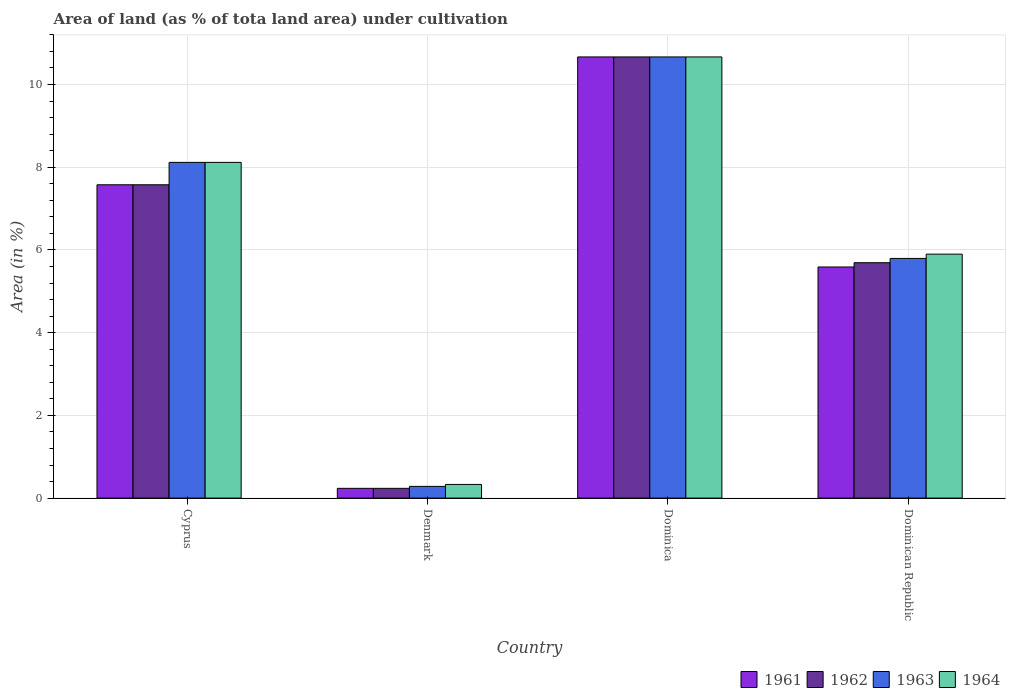How many groups of bars are there?
Make the answer very short. 4. Are the number of bars per tick equal to the number of legend labels?
Offer a very short reply. Yes. Are the number of bars on each tick of the X-axis equal?
Provide a short and direct response. Yes. How many bars are there on the 4th tick from the left?
Ensure brevity in your answer.  4. What is the label of the 4th group of bars from the left?
Make the answer very short. Dominican Republic. What is the percentage of land under cultivation in 1961 in Dominica?
Make the answer very short. 10.67. Across all countries, what is the maximum percentage of land under cultivation in 1964?
Keep it short and to the point. 10.67. Across all countries, what is the minimum percentage of land under cultivation in 1964?
Offer a very short reply. 0.33. In which country was the percentage of land under cultivation in 1961 maximum?
Your answer should be compact. Dominica. In which country was the percentage of land under cultivation in 1963 minimum?
Offer a terse response. Denmark. What is the total percentage of land under cultivation in 1961 in the graph?
Keep it short and to the point. 24.07. What is the difference between the percentage of land under cultivation in 1962 in Dominica and that in Dominican Republic?
Give a very brief answer. 4.98. What is the difference between the percentage of land under cultivation in 1964 in Cyprus and the percentage of land under cultivation in 1963 in Denmark?
Provide a succinct answer. 7.83. What is the average percentage of land under cultivation in 1961 per country?
Keep it short and to the point. 6.02. What is the difference between the percentage of land under cultivation of/in 1964 and percentage of land under cultivation of/in 1962 in Denmark?
Provide a succinct answer. 0.09. In how many countries, is the percentage of land under cultivation in 1962 greater than 4.8 %?
Provide a succinct answer. 3. What is the ratio of the percentage of land under cultivation in 1961 in Dominica to that in Dominican Republic?
Ensure brevity in your answer.  1.91. Is the percentage of land under cultivation in 1964 in Cyprus less than that in Denmark?
Your answer should be very brief. No. What is the difference between the highest and the second highest percentage of land under cultivation in 1963?
Offer a very short reply. -2.55. What is the difference between the highest and the lowest percentage of land under cultivation in 1963?
Make the answer very short. 10.38. In how many countries, is the percentage of land under cultivation in 1962 greater than the average percentage of land under cultivation in 1962 taken over all countries?
Your response must be concise. 2. What does the 4th bar from the right in Cyprus represents?
Provide a short and direct response. 1961. Is it the case that in every country, the sum of the percentage of land under cultivation in 1961 and percentage of land under cultivation in 1964 is greater than the percentage of land under cultivation in 1963?
Ensure brevity in your answer.  Yes. How many bars are there?
Offer a terse response. 16. How many countries are there in the graph?
Ensure brevity in your answer.  4. Are the values on the major ticks of Y-axis written in scientific E-notation?
Your response must be concise. No. Does the graph contain any zero values?
Ensure brevity in your answer.  No. Where does the legend appear in the graph?
Ensure brevity in your answer.  Bottom right. How are the legend labels stacked?
Ensure brevity in your answer.  Horizontal. What is the title of the graph?
Ensure brevity in your answer.  Area of land (as % of tota land area) under cultivation. Does "1988" appear as one of the legend labels in the graph?
Your response must be concise. No. What is the label or title of the X-axis?
Provide a short and direct response. Country. What is the label or title of the Y-axis?
Provide a succinct answer. Area (in %). What is the Area (in %) in 1961 in Cyprus?
Ensure brevity in your answer.  7.58. What is the Area (in %) in 1962 in Cyprus?
Your response must be concise. 7.58. What is the Area (in %) in 1963 in Cyprus?
Offer a terse response. 8.12. What is the Area (in %) in 1964 in Cyprus?
Offer a terse response. 8.12. What is the Area (in %) in 1961 in Denmark?
Keep it short and to the point. 0.24. What is the Area (in %) of 1962 in Denmark?
Provide a short and direct response. 0.24. What is the Area (in %) of 1963 in Denmark?
Provide a succinct answer. 0.28. What is the Area (in %) in 1964 in Denmark?
Offer a terse response. 0.33. What is the Area (in %) of 1961 in Dominica?
Ensure brevity in your answer.  10.67. What is the Area (in %) of 1962 in Dominica?
Provide a short and direct response. 10.67. What is the Area (in %) in 1963 in Dominica?
Make the answer very short. 10.67. What is the Area (in %) of 1964 in Dominica?
Your answer should be very brief. 10.67. What is the Area (in %) in 1961 in Dominican Republic?
Your answer should be very brief. 5.59. What is the Area (in %) of 1962 in Dominican Republic?
Provide a succinct answer. 5.69. What is the Area (in %) in 1963 in Dominican Republic?
Provide a succinct answer. 5.79. What is the Area (in %) of 1964 in Dominican Republic?
Keep it short and to the point. 5.9. Across all countries, what is the maximum Area (in %) of 1961?
Provide a succinct answer. 10.67. Across all countries, what is the maximum Area (in %) in 1962?
Your response must be concise. 10.67. Across all countries, what is the maximum Area (in %) of 1963?
Provide a short and direct response. 10.67. Across all countries, what is the maximum Area (in %) of 1964?
Give a very brief answer. 10.67. Across all countries, what is the minimum Area (in %) in 1961?
Keep it short and to the point. 0.24. Across all countries, what is the minimum Area (in %) of 1962?
Offer a terse response. 0.24. Across all countries, what is the minimum Area (in %) in 1963?
Provide a short and direct response. 0.28. Across all countries, what is the minimum Area (in %) in 1964?
Provide a short and direct response. 0.33. What is the total Area (in %) of 1961 in the graph?
Your answer should be compact. 24.07. What is the total Area (in %) in 1962 in the graph?
Give a very brief answer. 24.17. What is the total Area (in %) in 1963 in the graph?
Your answer should be very brief. 24.86. What is the total Area (in %) of 1964 in the graph?
Ensure brevity in your answer.  25.01. What is the difference between the Area (in %) in 1961 in Cyprus and that in Denmark?
Offer a terse response. 7.34. What is the difference between the Area (in %) of 1962 in Cyprus and that in Denmark?
Provide a short and direct response. 7.34. What is the difference between the Area (in %) of 1963 in Cyprus and that in Denmark?
Offer a very short reply. 7.83. What is the difference between the Area (in %) of 1964 in Cyprus and that in Denmark?
Your answer should be compact. 7.79. What is the difference between the Area (in %) in 1961 in Cyprus and that in Dominica?
Provide a succinct answer. -3.09. What is the difference between the Area (in %) in 1962 in Cyprus and that in Dominica?
Offer a terse response. -3.09. What is the difference between the Area (in %) in 1963 in Cyprus and that in Dominica?
Offer a very short reply. -2.55. What is the difference between the Area (in %) of 1964 in Cyprus and that in Dominica?
Provide a short and direct response. -2.55. What is the difference between the Area (in %) in 1961 in Cyprus and that in Dominican Republic?
Your answer should be compact. 1.99. What is the difference between the Area (in %) in 1962 in Cyprus and that in Dominican Republic?
Give a very brief answer. 1.88. What is the difference between the Area (in %) in 1963 in Cyprus and that in Dominican Republic?
Provide a succinct answer. 2.32. What is the difference between the Area (in %) of 1964 in Cyprus and that in Dominican Republic?
Provide a succinct answer. 2.22. What is the difference between the Area (in %) of 1961 in Denmark and that in Dominica?
Keep it short and to the point. -10.43. What is the difference between the Area (in %) in 1962 in Denmark and that in Dominica?
Offer a very short reply. -10.43. What is the difference between the Area (in %) of 1963 in Denmark and that in Dominica?
Keep it short and to the point. -10.38. What is the difference between the Area (in %) of 1964 in Denmark and that in Dominica?
Keep it short and to the point. -10.34. What is the difference between the Area (in %) of 1961 in Denmark and that in Dominican Republic?
Provide a succinct answer. -5.35. What is the difference between the Area (in %) in 1962 in Denmark and that in Dominican Republic?
Ensure brevity in your answer.  -5.46. What is the difference between the Area (in %) in 1963 in Denmark and that in Dominican Republic?
Your answer should be very brief. -5.51. What is the difference between the Area (in %) in 1964 in Denmark and that in Dominican Republic?
Keep it short and to the point. -5.57. What is the difference between the Area (in %) in 1961 in Dominica and that in Dominican Republic?
Ensure brevity in your answer.  5.08. What is the difference between the Area (in %) in 1962 in Dominica and that in Dominican Republic?
Your response must be concise. 4.98. What is the difference between the Area (in %) of 1963 in Dominica and that in Dominican Republic?
Offer a terse response. 4.87. What is the difference between the Area (in %) in 1964 in Dominica and that in Dominican Republic?
Offer a terse response. 4.77. What is the difference between the Area (in %) in 1961 in Cyprus and the Area (in %) in 1962 in Denmark?
Your answer should be compact. 7.34. What is the difference between the Area (in %) in 1961 in Cyprus and the Area (in %) in 1963 in Denmark?
Your answer should be compact. 7.29. What is the difference between the Area (in %) of 1961 in Cyprus and the Area (in %) of 1964 in Denmark?
Provide a succinct answer. 7.25. What is the difference between the Area (in %) of 1962 in Cyprus and the Area (in %) of 1963 in Denmark?
Give a very brief answer. 7.29. What is the difference between the Area (in %) of 1962 in Cyprus and the Area (in %) of 1964 in Denmark?
Make the answer very short. 7.25. What is the difference between the Area (in %) in 1963 in Cyprus and the Area (in %) in 1964 in Denmark?
Your response must be concise. 7.79. What is the difference between the Area (in %) in 1961 in Cyprus and the Area (in %) in 1962 in Dominica?
Provide a short and direct response. -3.09. What is the difference between the Area (in %) in 1961 in Cyprus and the Area (in %) in 1963 in Dominica?
Your response must be concise. -3.09. What is the difference between the Area (in %) of 1961 in Cyprus and the Area (in %) of 1964 in Dominica?
Provide a short and direct response. -3.09. What is the difference between the Area (in %) in 1962 in Cyprus and the Area (in %) in 1963 in Dominica?
Ensure brevity in your answer.  -3.09. What is the difference between the Area (in %) in 1962 in Cyprus and the Area (in %) in 1964 in Dominica?
Ensure brevity in your answer.  -3.09. What is the difference between the Area (in %) in 1963 in Cyprus and the Area (in %) in 1964 in Dominica?
Provide a short and direct response. -2.55. What is the difference between the Area (in %) in 1961 in Cyprus and the Area (in %) in 1962 in Dominican Republic?
Keep it short and to the point. 1.88. What is the difference between the Area (in %) of 1961 in Cyprus and the Area (in %) of 1963 in Dominican Republic?
Offer a terse response. 1.78. What is the difference between the Area (in %) in 1961 in Cyprus and the Area (in %) in 1964 in Dominican Republic?
Provide a succinct answer. 1.68. What is the difference between the Area (in %) of 1962 in Cyprus and the Area (in %) of 1963 in Dominican Republic?
Ensure brevity in your answer.  1.78. What is the difference between the Area (in %) of 1962 in Cyprus and the Area (in %) of 1964 in Dominican Republic?
Offer a very short reply. 1.68. What is the difference between the Area (in %) in 1963 in Cyprus and the Area (in %) in 1964 in Dominican Republic?
Ensure brevity in your answer.  2.22. What is the difference between the Area (in %) of 1961 in Denmark and the Area (in %) of 1962 in Dominica?
Your answer should be compact. -10.43. What is the difference between the Area (in %) in 1961 in Denmark and the Area (in %) in 1963 in Dominica?
Offer a very short reply. -10.43. What is the difference between the Area (in %) in 1961 in Denmark and the Area (in %) in 1964 in Dominica?
Make the answer very short. -10.43. What is the difference between the Area (in %) in 1962 in Denmark and the Area (in %) in 1963 in Dominica?
Give a very brief answer. -10.43. What is the difference between the Area (in %) of 1962 in Denmark and the Area (in %) of 1964 in Dominica?
Your answer should be very brief. -10.43. What is the difference between the Area (in %) of 1963 in Denmark and the Area (in %) of 1964 in Dominica?
Your response must be concise. -10.38. What is the difference between the Area (in %) of 1961 in Denmark and the Area (in %) of 1962 in Dominican Republic?
Provide a short and direct response. -5.46. What is the difference between the Area (in %) in 1961 in Denmark and the Area (in %) in 1963 in Dominican Republic?
Give a very brief answer. -5.56. What is the difference between the Area (in %) in 1961 in Denmark and the Area (in %) in 1964 in Dominican Republic?
Provide a short and direct response. -5.66. What is the difference between the Area (in %) of 1962 in Denmark and the Area (in %) of 1963 in Dominican Republic?
Make the answer very short. -5.56. What is the difference between the Area (in %) in 1962 in Denmark and the Area (in %) in 1964 in Dominican Republic?
Your response must be concise. -5.66. What is the difference between the Area (in %) in 1963 in Denmark and the Area (in %) in 1964 in Dominican Republic?
Make the answer very short. -5.62. What is the difference between the Area (in %) of 1961 in Dominica and the Area (in %) of 1962 in Dominican Republic?
Provide a succinct answer. 4.98. What is the difference between the Area (in %) in 1961 in Dominica and the Area (in %) in 1963 in Dominican Republic?
Ensure brevity in your answer.  4.87. What is the difference between the Area (in %) in 1961 in Dominica and the Area (in %) in 1964 in Dominican Republic?
Offer a terse response. 4.77. What is the difference between the Area (in %) in 1962 in Dominica and the Area (in %) in 1963 in Dominican Republic?
Give a very brief answer. 4.87. What is the difference between the Area (in %) of 1962 in Dominica and the Area (in %) of 1964 in Dominican Republic?
Provide a succinct answer. 4.77. What is the difference between the Area (in %) in 1963 in Dominica and the Area (in %) in 1964 in Dominican Republic?
Offer a terse response. 4.77. What is the average Area (in %) in 1961 per country?
Offer a very short reply. 6.02. What is the average Area (in %) of 1962 per country?
Your answer should be very brief. 6.04. What is the average Area (in %) in 1963 per country?
Offer a very short reply. 6.22. What is the average Area (in %) of 1964 per country?
Your response must be concise. 6.25. What is the difference between the Area (in %) of 1961 and Area (in %) of 1963 in Cyprus?
Make the answer very short. -0.54. What is the difference between the Area (in %) of 1961 and Area (in %) of 1964 in Cyprus?
Your response must be concise. -0.54. What is the difference between the Area (in %) in 1962 and Area (in %) in 1963 in Cyprus?
Give a very brief answer. -0.54. What is the difference between the Area (in %) in 1962 and Area (in %) in 1964 in Cyprus?
Offer a terse response. -0.54. What is the difference between the Area (in %) of 1961 and Area (in %) of 1962 in Denmark?
Provide a short and direct response. 0. What is the difference between the Area (in %) in 1961 and Area (in %) in 1963 in Denmark?
Offer a very short reply. -0.05. What is the difference between the Area (in %) of 1961 and Area (in %) of 1964 in Denmark?
Offer a terse response. -0.09. What is the difference between the Area (in %) in 1962 and Area (in %) in 1963 in Denmark?
Your answer should be compact. -0.05. What is the difference between the Area (in %) of 1962 and Area (in %) of 1964 in Denmark?
Keep it short and to the point. -0.09. What is the difference between the Area (in %) of 1963 and Area (in %) of 1964 in Denmark?
Ensure brevity in your answer.  -0.05. What is the difference between the Area (in %) in 1961 and Area (in %) in 1963 in Dominica?
Keep it short and to the point. 0. What is the difference between the Area (in %) of 1961 and Area (in %) of 1964 in Dominica?
Ensure brevity in your answer.  0. What is the difference between the Area (in %) of 1962 and Area (in %) of 1964 in Dominica?
Offer a very short reply. 0. What is the difference between the Area (in %) in 1963 and Area (in %) in 1964 in Dominica?
Your answer should be very brief. 0. What is the difference between the Area (in %) of 1961 and Area (in %) of 1962 in Dominican Republic?
Offer a very short reply. -0.1. What is the difference between the Area (in %) of 1961 and Area (in %) of 1963 in Dominican Republic?
Provide a short and direct response. -0.21. What is the difference between the Area (in %) of 1961 and Area (in %) of 1964 in Dominican Republic?
Your answer should be compact. -0.31. What is the difference between the Area (in %) in 1962 and Area (in %) in 1963 in Dominican Republic?
Offer a terse response. -0.1. What is the difference between the Area (in %) in 1962 and Area (in %) in 1964 in Dominican Republic?
Make the answer very short. -0.21. What is the difference between the Area (in %) of 1963 and Area (in %) of 1964 in Dominican Republic?
Offer a very short reply. -0.1. What is the ratio of the Area (in %) of 1961 in Cyprus to that in Denmark?
Give a very brief answer. 32.1. What is the ratio of the Area (in %) of 1962 in Cyprus to that in Denmark?
Offer a terse response. 32.1. What is the ratio of the Area (in %) of 1963 in Cyprus to that in Denmark?
Give a very brief answer. 28.66. What is the ratio of the Area (in %) in 1964 in Cyprus to that in Denmark?
Keep it short and to the point. 24.57. What is the ratio of the Area (in %) of 1961 in Cyprus to that in Dominica?
Provide a short and direct response. 0.71. What is the ratio of the Area (in %) of 1962 in Cyprus to that in Dominica?
Ensure brevity in your answer.  0.71. What is the ratio of the Area (in %) of 1963 in Cyprus to that in Dominica?
Your answer should be very brief. 0.76. What is the ratio of the Area (in %) in 1964 in Cyprus to that in Dominica?
Offer a terse response. 0.76. What is the ratio of the Area (in %) of 1961 in Cyprus to that in Dominican Republic?
Keep it short and to the point. 1.36. What is the ratio of the Area (in %) in 1962 in Cyprus to that in Dominican Republic?
Give a very brief answer. 1.33. What is the ratio of the Area (in %) of 1963 in Cyprus to that in Dominican Republic?
Provide a short and direct response. 1.4. What is the ratio of the Area (in %) of 1964 in Cyprus to that in Dominican Republic?
Your response must be concise. 1.38. What is the ratio of the Area (in %) in 1961 in Denmark to that in Dominica?
Offer a terse response. 0.02. What is the ratio of the Area (in %) in 1962 in Denmark to that in Dominica?
Ensure brevity in your answer.  0.02. What is the ratio of the Area (in %) of 1963 in Denmark to that in Dominica?
Provide a succinct answer. 0.03. What is the ratio of the Area (in %) in 1964 in Denmark to that in Dominica?
Give a very brief answer. 0.03. What is the ratio of the Area (in %) of 1961 in Denmark to that in Dominican Republic?
Make the answer very short. 0.04. What is the ratio of the Area (in %) in 1962 in Denmark to that in Dominican Republic?
Provide a succinct answer. 0.04. What is the ratio of the Area (in %) of 1963 in Denmark to that in Dominican Republic?
Provide a short and direct response. 0.05. What is the ratio of the Area (in %) of 1964 in Denmark to that in Dominican Republic?
Give a very brief answer. 0.06. What is the ratio of the Area (in %) of 1961 in Dominica to that in Dominican Republic?
Provide a succinct answer. 1.91. What is the ratio of the Area (in %) of 1962 in Dominica to that in Dominican Republic?
Make the answer very short. 1.87. What is the ratio of the Area (in %) in 1963 in Dominica to that in Dominican Republic?
Make the answer very short. 1.84. What is the ratio of the Area (in %) of 1964 in Dominica to that in Dominican Republic?
Your answer should be compact. 1.81. What is the difference between the highest and the second highest Area (in %) in 1961?
Your answer should be compact. 3.09. What is the difference between the highest and the second highest Area (in %) of 1962?
Ensure brevity in your answer.  3.09. What is the difference between the highest and the second highest Area (in %) in 1963?
Your answer should be compact. 2.55. What is the difference between the highest and the second highest Area (in %) in 1964?
Ensure brevity in your answer.  2.55. What is the difference between the highest and the lowest Area (in %) of 1961?
Provide a succinct answer. 10.43. What is the difference between the highest and the lowest Area (in %) in 1962?
Your answer should be very brief. 10.43. What is the difference between the highest and the lowest Area (in %) of 1963?
Keep it short and to the point. 10.38. What is the difference between the highest and the lowest Area (in %) of 1964?
Keep it short and to the point. 10.34. 